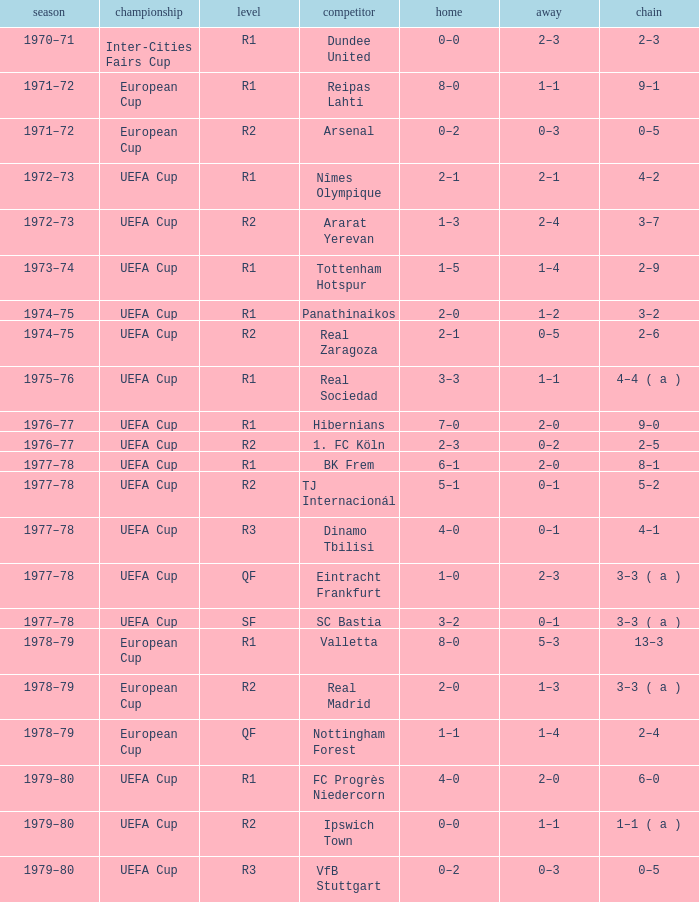Which Opponent has an Away of 1–1, and a Home of 3–3? Real Sociedad. 